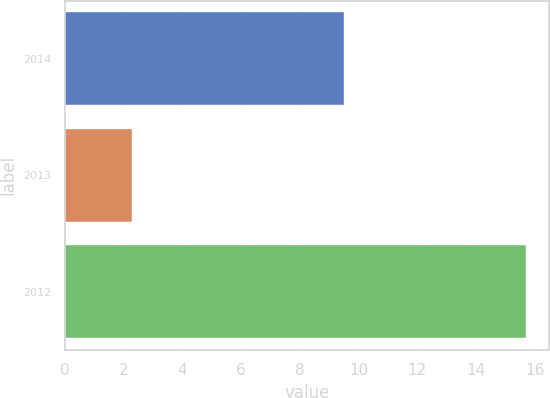Convert chart to OTSL. <chart><loc_0><loc_0><loc_500><loc_500><bar_chart><fcel>2014<fcel>2013<fcel>2012<nl><fcel>9.5<fcel>2.3<fcel>15.7<nl></chart> 